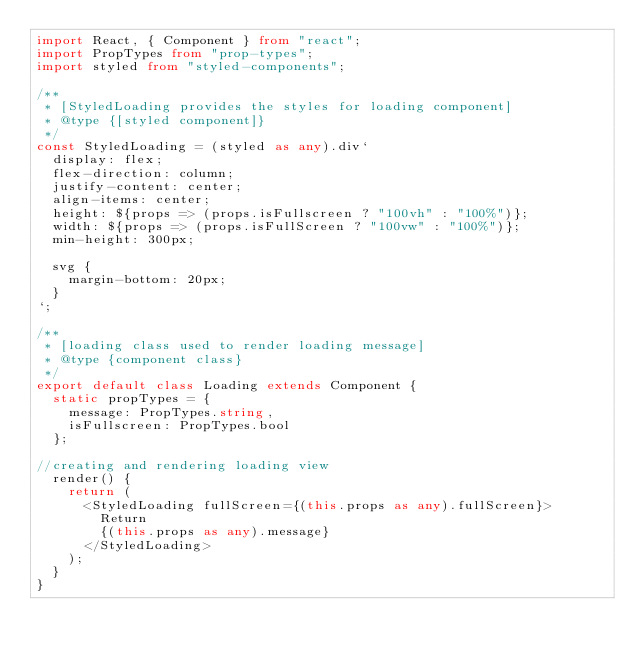Convert code to text. <code><loc_0><loc_0><loc_500><loc_500><_TypeScript_>import React, { Component } from "react";
import PropTypes from "prop-types";
import styled from "styled-components";

/**
 * [StyledLoading provides the styles for loading component]
 * @type {[styled component]}
 */
const StyledLoading = (styled as any).div`
  display: flex;
  flex-direction: column;
  justify-content: center;
  align-items: center;
  height: ${props => (props.isFullscreen ? "100vh" : "100%")};
  width: ${props => (props.isFullScreen ? "100vw" : "100%")};
  min-height: 300px;

  svg {
    margin-bottom: 20px;
  }
`;

/**
 * [loading class used to render loading message]
 * @type {component class}
 */
export default class Loading extends Component {
  static propTypes = {
    message: PropTypes.string,
    isFullscreen: PropTypes.bool
  };

//creating and rendering loading view
  render() {
    return (
      <StyledLoading fullScreen={(this.props as any).fullScreen}>
        Return
        {(this.props as any).message}
      </StyledLoading>
    );
  }
}
</code> 